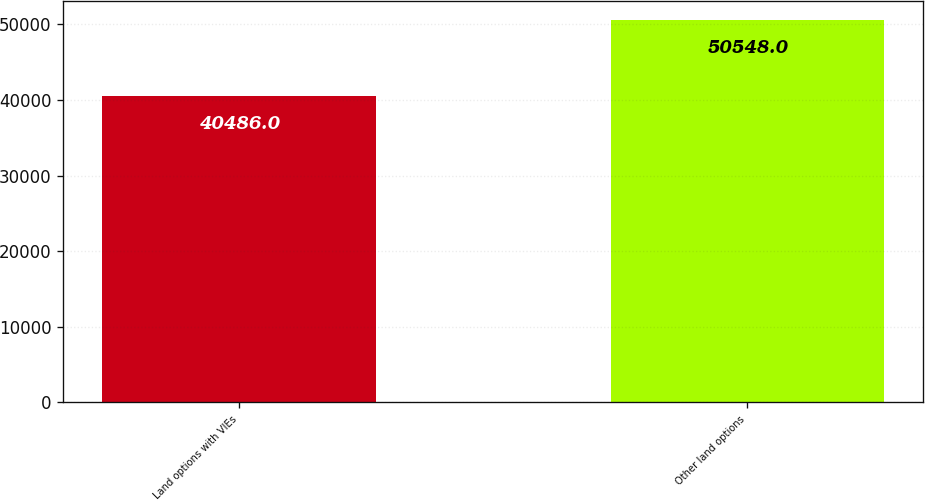Convert chart to OTSL. <chart><loc_0><loc_0><loc_500><loc_500><bar_chart><fcel>Land options with VIEs<fcel>Other land options<nl><fcel>40486<fcel>50548<nl></chart> 